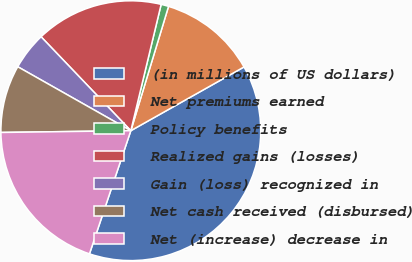<chart> <loc_0><loc_0><loc_500><loc_500><pie_chart><fcel>(in millions of US dollars)<fcel>Net premiums earned<fcel>Policy benefits<fcel>Realized gains (losses)<fcel>Gain (loss) recognized in<fcel>Net cash received (disbursed)<fcel>Net (increase) decrease in<nl><fcel>38.32%<fcel>12.15%<fcel>0.94%<fcel>15.89%<fcel>4.67%<fcel>8.41%<fcel>19.63%<nl></chart> 